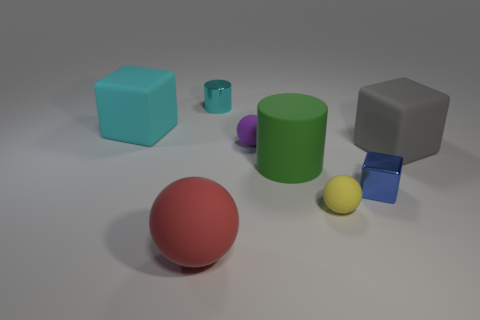The small thing that is both in front of the cyan cylinder and behind the big gray object is made of what material?
Make the answer very short. Rubber. How many other large green matte things have the same shape as the large green thing?
Ensure brevity in your answer.  0. There is a shiny thing in front of the matte cube that is on the right side of the large rubber block to the left of the small yellow matte ball; how big is it?
Provide a succinct answer. Small. Is the number of purple matte balls that are behind the small cylinder greater than the number of big gray rubber cubes?
Your response must be concise. No. Is there a rubber cylinder?
Your answer should be very brief. Yes. What number of gray rubber cubes have the same size as the blue cube?
Keep it short and to the point. 0. Is the number of tiny shiny objects in front of the green matte object greater than the number of metal cubes in front of the red object?
Provide a short and direct response. Yes. There is a cyan object that is the same size as the red thing; what is its material?
Keep it short and to the point. Rubber. What is the shape of the purple rubber object?
Provide a short and direct response. Sphere. How many blue objects are either tiny metal objects or matte cylinders?
Your answer should be very brief. 1. 